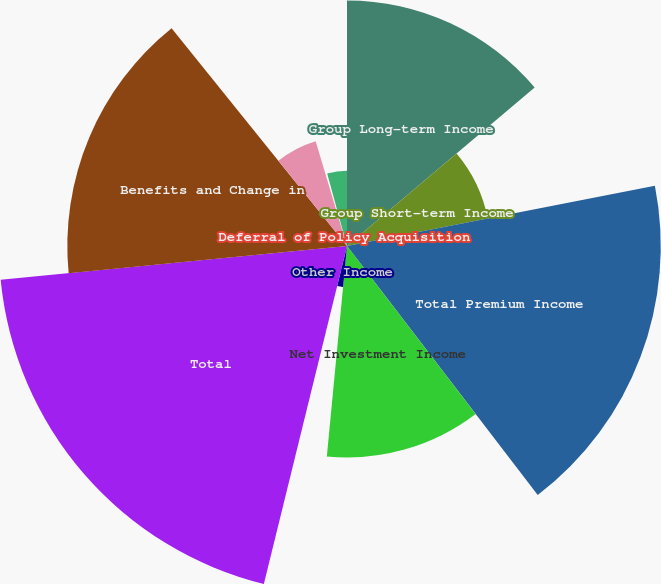<chart> <loc_0><loc_0><loc_500><loc_500><pie_chart><fcel>Group Long-term Income<fcel>Group Short-term Income<fcel>Total Premium Income<fcel>Net Investment Income<fcel>Other Income<fcel>Total<fcel>Benefits and Change in<fcel>Commissions<fcel>Deferral of Policy Acquisition<fcel>Amortization of Deferred<nl><fcel>13.84%<fcel>8.08%<fcel>17.68%<fcel>11.92%<fcel>2.32%<fcel>19.61%<fcel>15.76%<fcel>6.16%<fcel>0.39%<fcel>4.24%<nl></chart> 